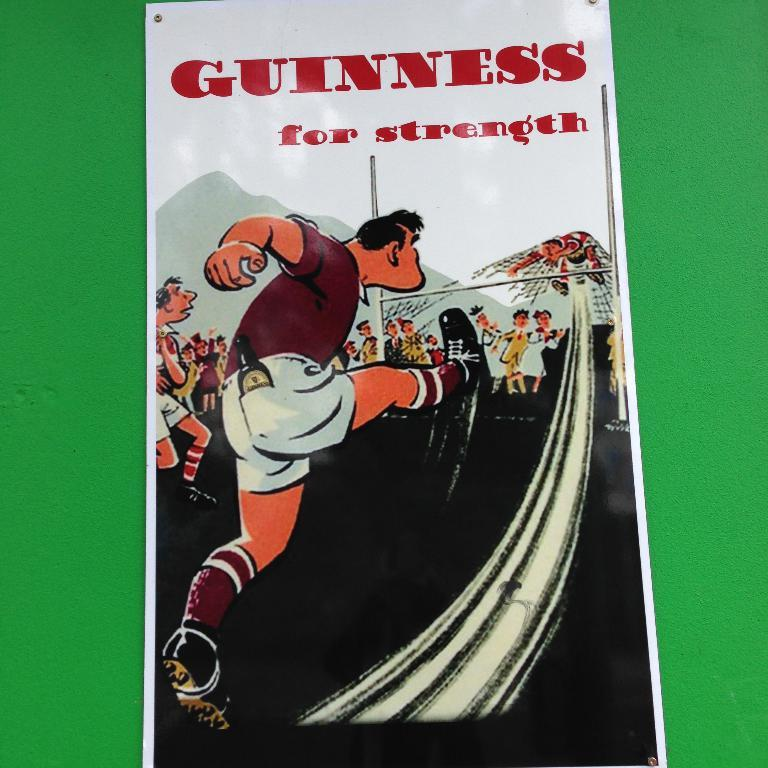<image>
Offer a succinct explanation of the picture presented. Poster showing a man kicking and the words "Guiness for Strength". 